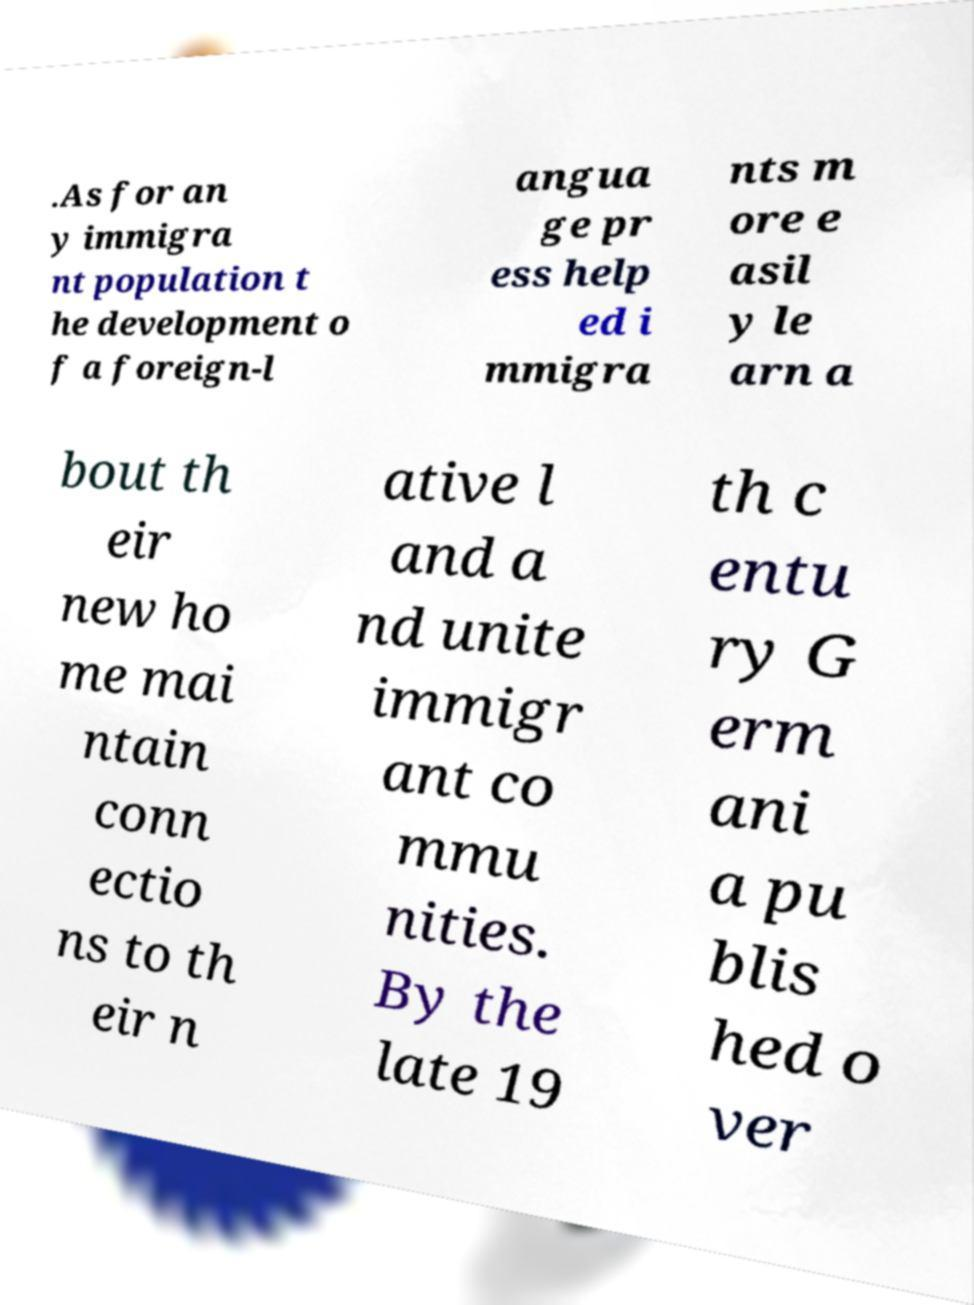Please read and relay the text visible in this image. What does it say? .As for an y immigra nt population t he development o f a foreign-l angua ge pr ess help ed i mmigra nts m ore e asil y le arn a bout th eir new ho me mai ntain conn ectio ns to th eir n ative l and a nd unite immigr ant co mmu nities. By the late 19 th c entu ry G erm ani a pu blis hed o ver 